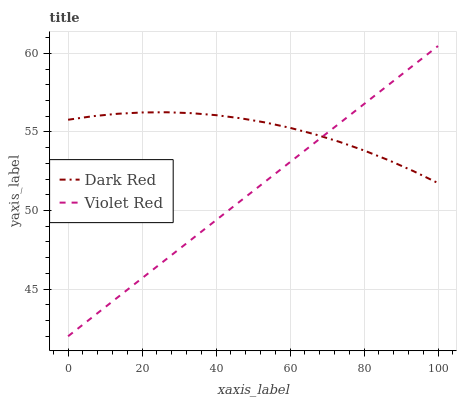Does Violet Red have the minimum area under the curve?
Answer yes or no. Yes. Does Dark Red have the maximum area under the curve?
Answer yes or no. Yes. Does Violet Red have the maximum area under the curve?
Answer yes or no. No. Is Violet Red the smoothest?
Answer yes or no. Yes. Is Dark Red the roughest?
Answer yes or no. Yes. Is Violet Red the roughest?
Answer yes or no. No. Does Violet Red have the lowest value?
Answer yes or no. Yes. Does Violet Red have the highest value?
Answer yes or no. Yes. Does Dark Red intersect Violet Red?
Answer yes or no. Yes. Is Dark Red less than Violet Red?
Answer yes or no. No. Is Dark Red greater than Violet Red?
Answer yes or no. No. 